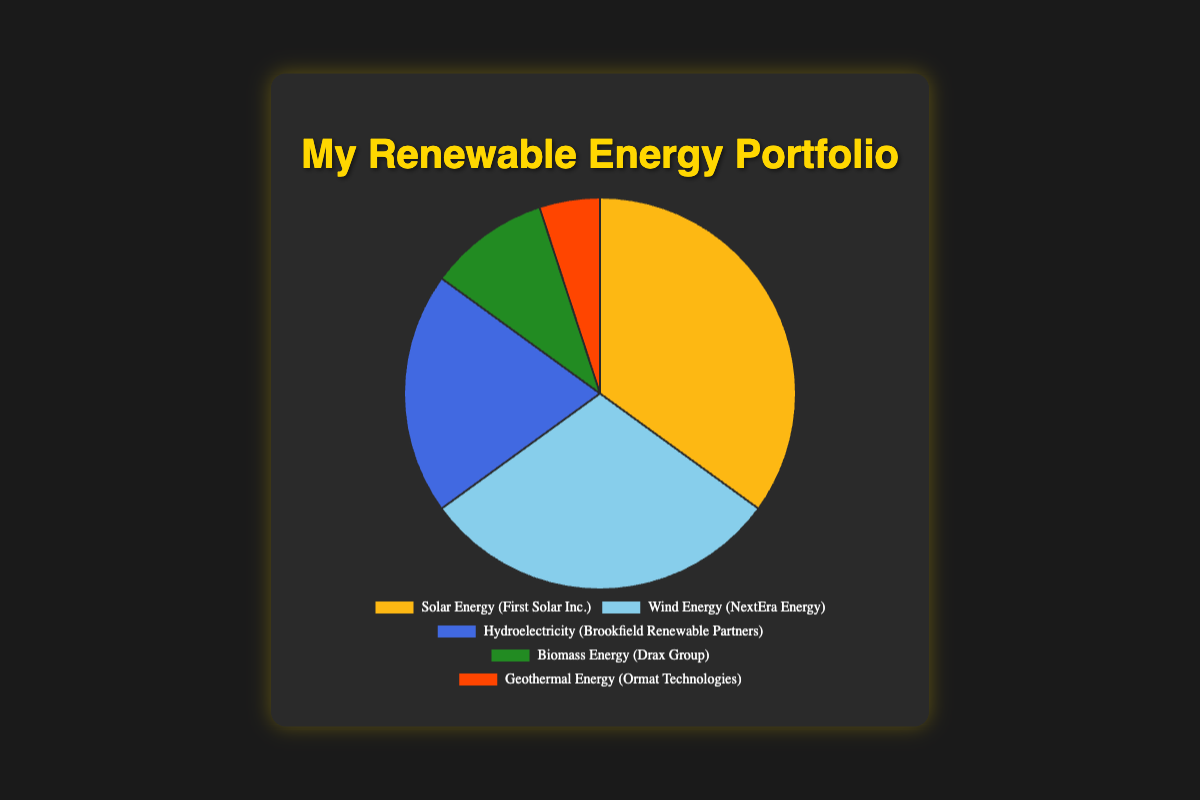What percentage of the revenue comes from Solar Energy? Look at the pie chart section labeled "Solar Energy (First Solar Inc.)". The label indicates that Solar Energy accounts for 35% of the revenue.
Answer: 35% Which energy source generates more revenue: Wind Energy or Biomass Energy? Compare the sections of the pie chart labeled "Wind Energy (NextEra Energy)" and "Biomass Energy (Drax Group)". Wind Energy has a larger section, corresponding to 30%, while Biomass Energy accounts for only 10%.
Answer: Wind Energy How much more revenue does Hydroelectricity generate compared to Geothermal Energy? Find the percentages for Hydroelectricity (20%) and Geothermal Energy (5%) on the pie chart. Subtract Geothermal's percentage from Hydroelectricity's: 20% - 5% = 15%.
Answer: 15% What is the combined revenue percentage of Solar Energy and Wind Energy? Identify the percentages for Solar Energy (35%) and Wind Energy (30%) on the pie chart. Add them together: 35% + 30% = 65%.
Answer: 65% Which energy source generates the least revenue? Look at the pie chart and identify the smallest section. The label "Geothermal Energy (Ormat Technologies)" corresponds to the smallest percentage, which is 5%.
Answer: Geothermal Energy Is the revenue from Hydroelectricity greater than the combined revenue from Biomass Energy and Geothermal Energy? Hydroelectricity accounts for 20% of the revenue. Biomass Energy and Geothermal Energy together account for 10% + 5% = 15%. Since 20% is greater than 15%, Hydroelectricity generates more revenue.
Answer: Yes What is the average revenue percentage for all the energy sources? Sum the percentages for all energy sources: 35% + 30% + 20% + 10% + 5% = 100%. There are 5 sources. The average percentage is 100% / 5 = 20%.
Answer: 20% What color represents Biomass Energy in the pie chart? Biomass Energy (Drax Group) is represented by a section in the pie chart colored green.
Answer: Green What is the ratio of the revenue percentage of Solar Energy to Wind Energy? Compare the revenue percentages for Solar Energy (35%) and Wind Energy (30%). The ratio is 35:30, which simplifies to 7:6.
Answer: 7:6 If a new renewable energy source is added and it generates 10% of the revenue, what would be the new total revenue percentage of Solar and Wind Energy combined? The current combined revenue percentage for Solar and Wind Energy is 65%. Adding a new source with 10% does not change their combined total. So, the new combined percentage remains 35% + 30% = 65%.
Answer: 65% 